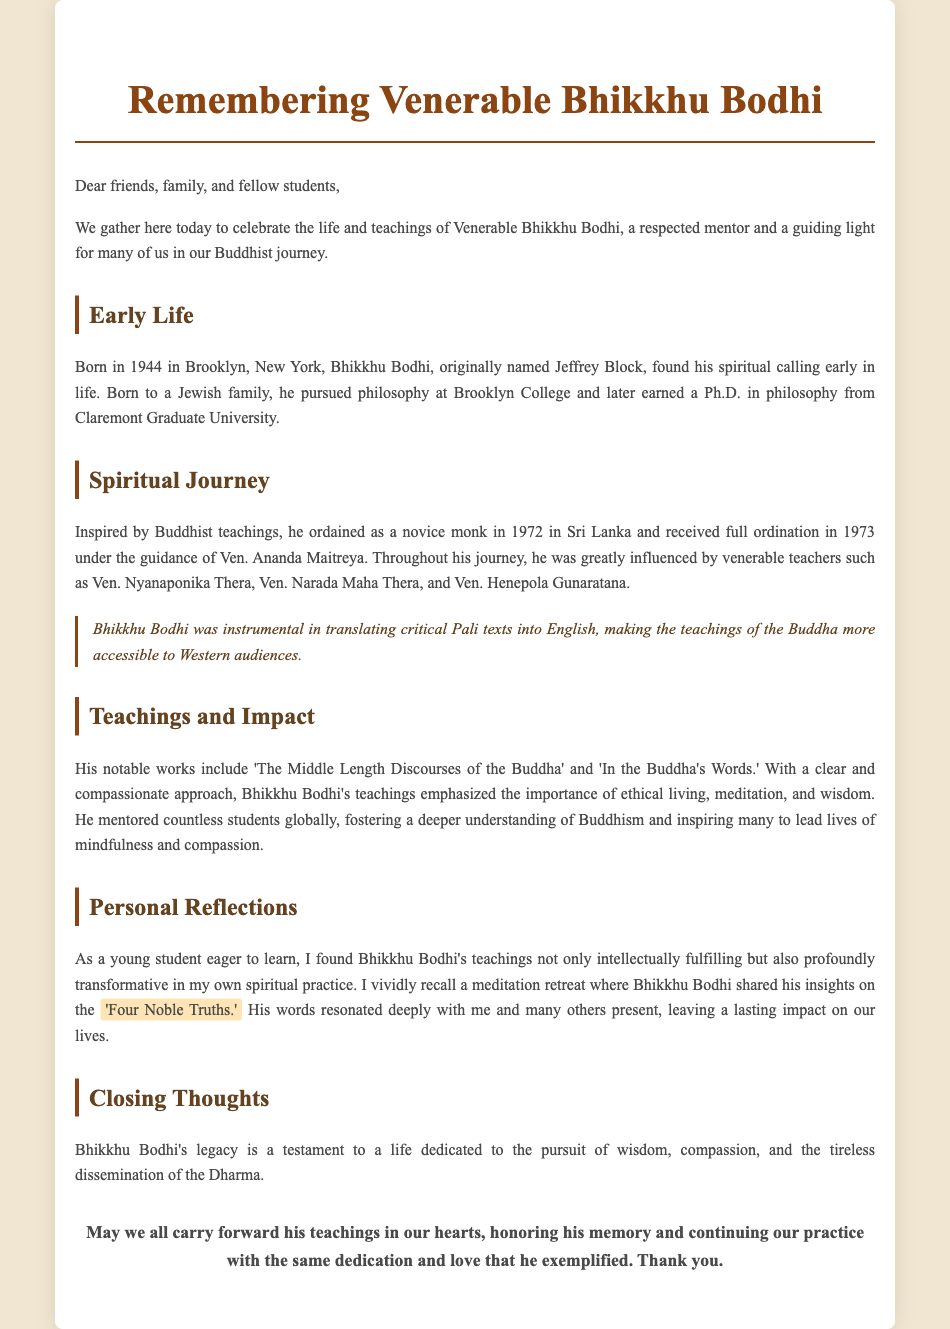What was Venerable Bhikkhu Bodhi's birth name? Venerable Bhikkhu Bodhi was originally named Jeffrey Block.
Answer: Jeffrey Block In what year was Bhikkhu Bodhi born? The document states that Bhikkhu Bodhi was born in 1944.
Answer: 1944 What significant texts did Bhikkhu Bodhi translate? He was instrumental in translating critical Pali texts into English.
Answer: Critical Pali texts What is one of Bhikkhu Bodhi's notable works? The document mentions 'The Middle Length Discourses of the Buddha' as one of his notable works.
Answer: The Middle Length Discourses of the Buddha Who did Bhikkhu Bodhi ordain under? He received full ordination under the guidance of Ven. Ananda Maitreya.
Answer: Ven. Ananda Maitreya What key teaching did Bhikkhu Bodhi emphasize in his teachings? He emphasized the importance of ethical living, meditation, and wisdom.
Answer: Ethical living, meditation, and wisdom Which meditation topic left a lasting impact on the students during the retreat? Bhikkhu Bodhi shared insights on the 'Four Noble Truths.'
Answer: Four Noble Truths What legacy did Bhikkhu Bodhi leave behind? His legacy is a testament to a life dedicated to the pursuit of wisdom, compassion, and the tireless dissemination of the Dharma.
Answer: Wisdom, compassion, and dissemination of the Dharma 